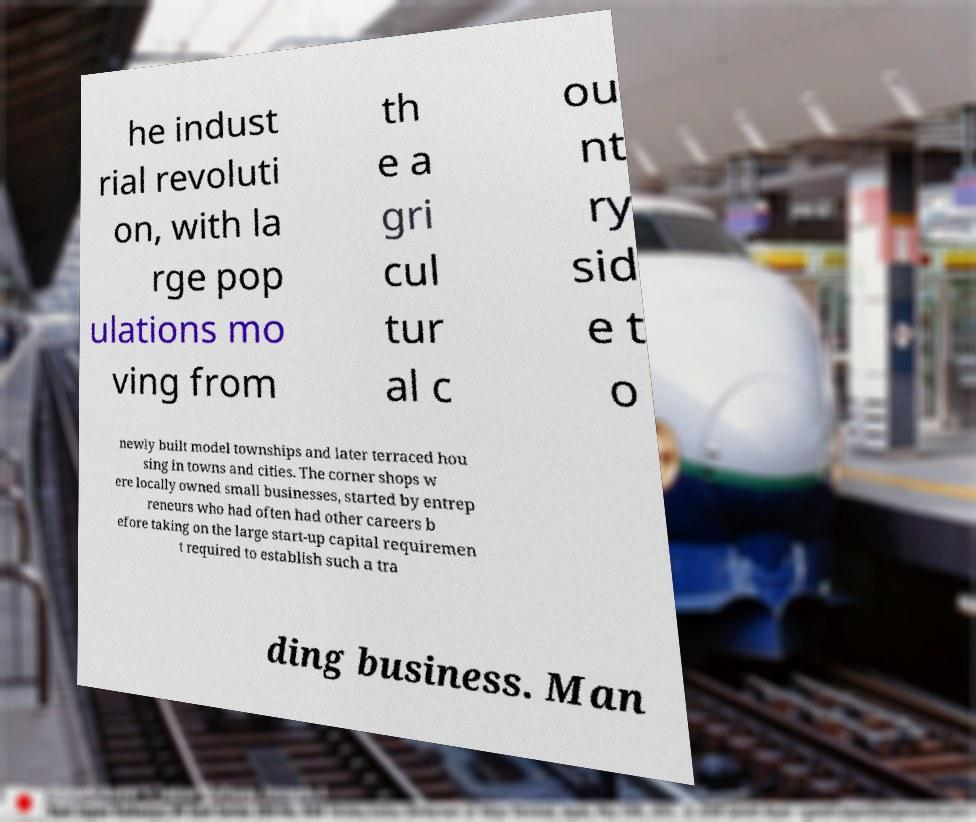Could you extract and type out the text from this image? he indust rial revoluti on, with la rge pop ulations mo ving from th e a gri cul tur al c ou nt ry sid e t o newly built model townships and later terraced hou sing in towns and cities. The corner shops w ere locally owned small businesses, started by entrep reneurs who had often had other careers b efore taking on the large start-up capital requiremen t required to establish such a tra ding business. Man 